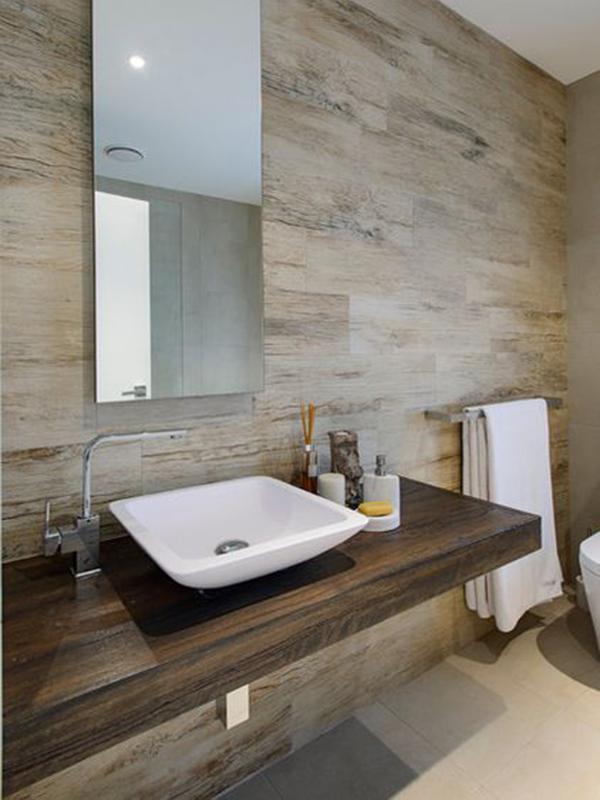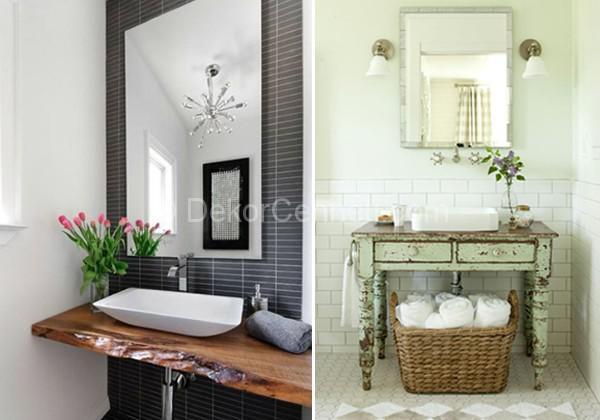The first image is the image on the left, the second image is the image on the right. Analyze the images presented: Is the assertion "A mirror sits behind the sink in each of the images." valid? Answer yes or no. Yes. The first image is the image on the left, the second image is the image on the right. Examine the images to the left and right. Is the description "All sinks shown sit on top of a vanity, at least some vanities have wood grain, and white towels are underneath at least one vanity." accurate? Answer yes or no. Yes. 